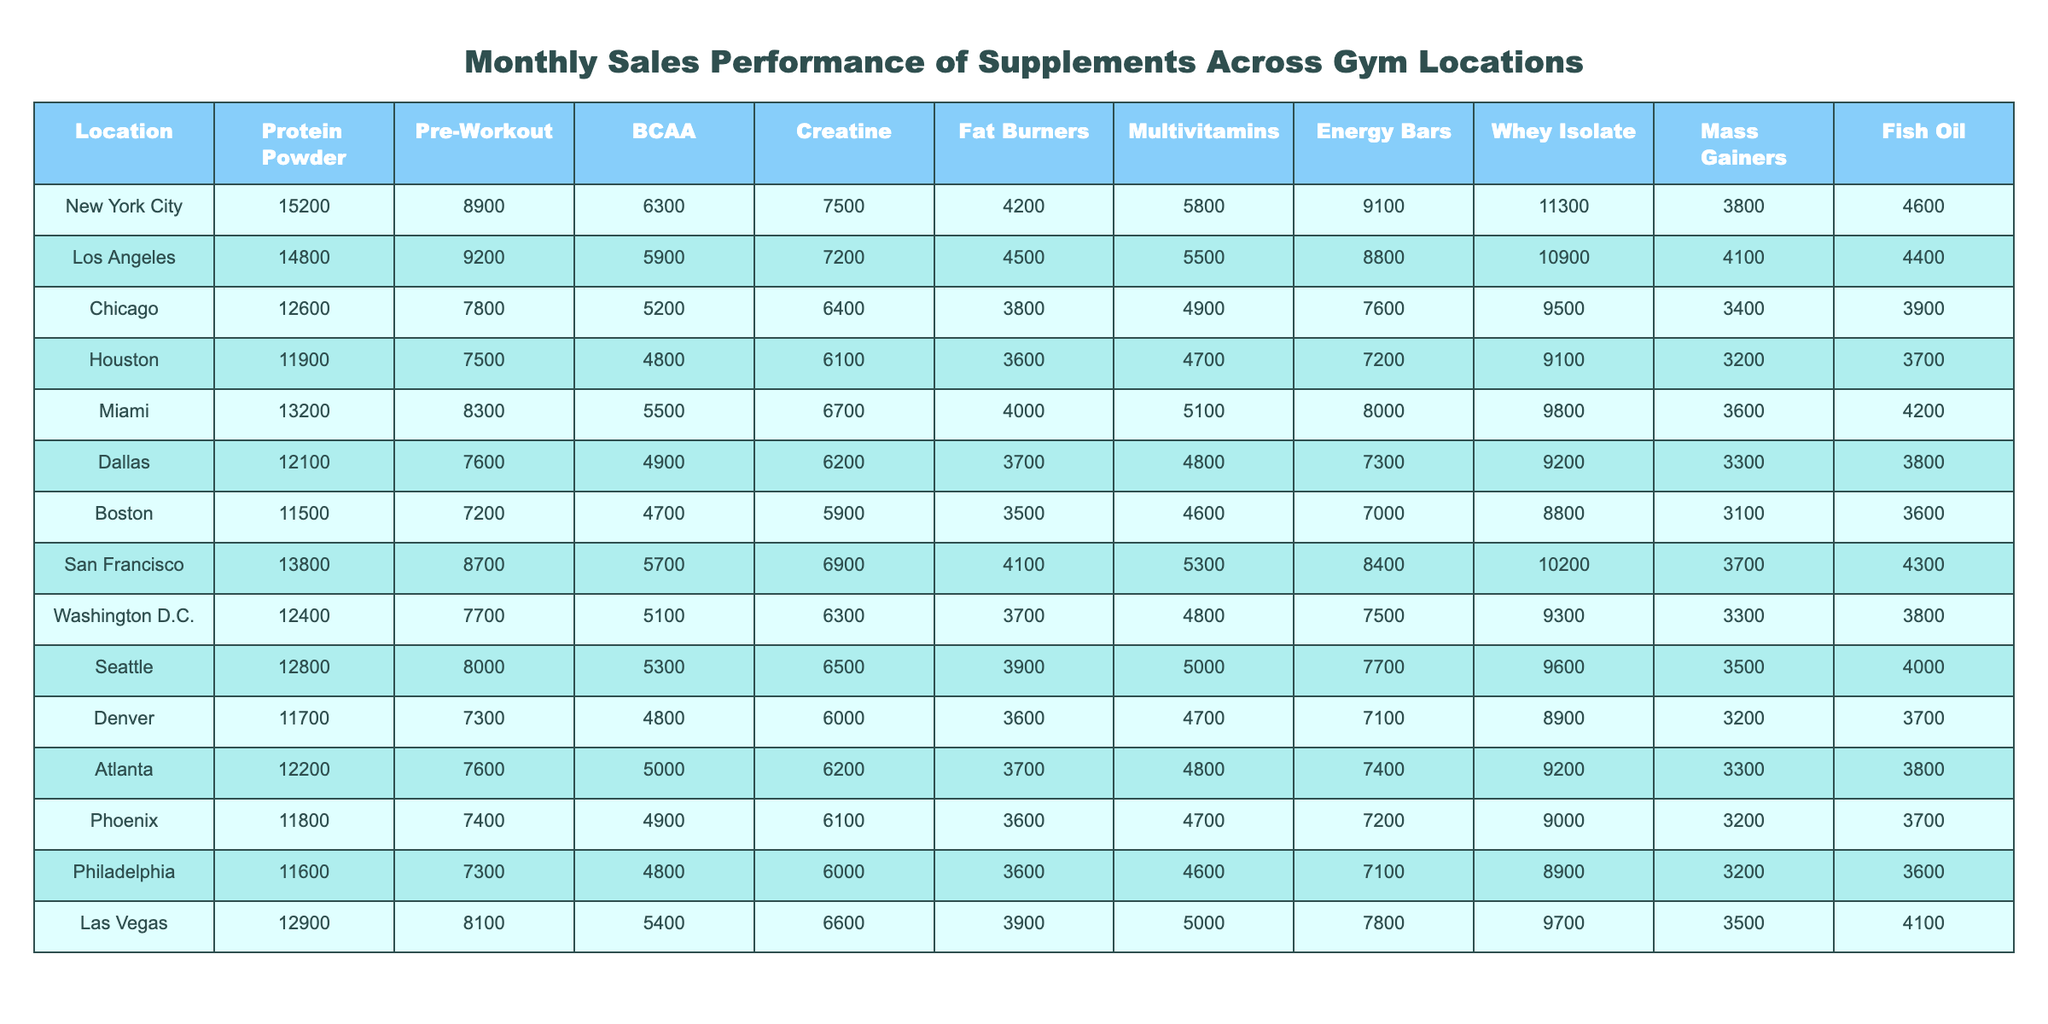What is the highest selling supplement in New York City? In the table for New York City, the highest sales figure corresponds to the Protein Powder, which is 15,200.
Answer: 15,200 Which location sold the most Whey Isolate? The table shows that San Francisco sold the most Whey Isolate with a total of 10,200.
Answer: 10,200 What is the total sales of Fat Burners across all locations? To find this, sum the values for Fat Burners: 4,200 + 4,500 + 3,800 + 3,600 + 4,000 + 3,700 + 3,500 + 4,100 + 3,700 + 3,600 + 3,900 + 3,600 =  46,400.
Answer: 46,400 Is the sales figure for Pre-Workout in Chicago greater than the average sales for the same supplement across all locations? First, find the average sales for Pre-Workout. Sales are: 8,900, 9,200, 7,800, 7,500, 8,300, 7,600, 7,200, 8,700, 7,700, 8,000, 7,300, 7,600, which total  101,300 over 12 locations, hence the average is 8,441.67. Chicago's sales are 7,800, which is less than 8,441.67.
Answer: No Which location has the lowest sales of Mass Gainers? By inspecting the Mass Gainers column, the lowest sales value is in Boston at 3,100.
Answer: Boston What is the difference in sales of BCAA between Los Angeles and Houston? The difference is calculated by subtracting Houston's BCAA sales (4,800) from Los Angeles' BCAA sales (5,900): 5,900 - 4,800 = 1,100.
Answer: 1,100 Which supplement had the highest total sales in San Francisco? Looking at the San Francisco row, Protein Powder had the highest sales at 13,800 compared to the other supplements listed.
Answer: 13,800 What is the average sales of Energy Bars across all gym locations? Summing the Energy Bar sales: 9,100 + 8,800 + 7,600 + 7,200 + 8,000 + 7,300 + 7,000 + 8,400 + 7,500 + 7,700 + 7,100 + 7,800 gives  88,800. Therefore the average sales are 88,800 / 12 = 7,400.
Answer: 7,400 Is Miami's sales for Creatine higher than the average sales for Creatine across all locations? Average sales for Creatine are determined by taking these values: 7,500, 7,200, 6,400, 6,100, 6,700, 6,200, 5,900, 6,900, 6,500, 6,300, 6,000, 6,600, which total 7,000 and give an average of 6,083. Miami’s sales of 6,700 are higher than this average.
Answer: Yes What are the two locations with sales of Multivitamins over 5,100? Inspecting the Multivitamins column, the sales over 5,100 are found in New York City (5,800), Los Angeles (5,500), Miami (5,100), San Francisco (5,300), and Las Vegas (5,000). The locations with sales over 5,100 are New York City and San Francisco.
Answer: New York City and San Francisco How many locations sold more than 4,500 units of Fish Oil? By checking the Fish Oil column, the sales figures are: 4,600, 4,400, 3,900, 3,700, 4,200, 3,800, 3,600, 4,300, 3,500, 4,100, 3,600, 3,600. The locations with more than 4,500 units are New York City, Los Angeles, and San Francisco totaling 3 locations.
Answer: 3 